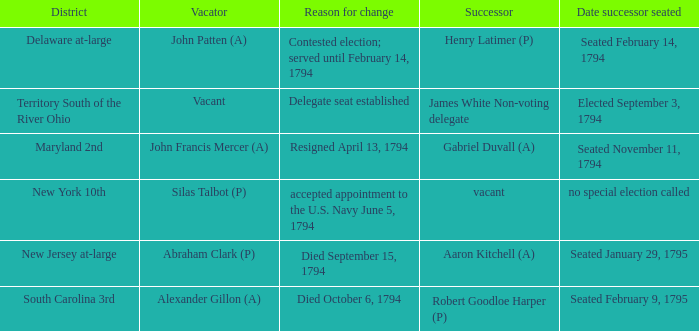Name the date successor seated is south carolina 3rd Seated February 9, 1795. 